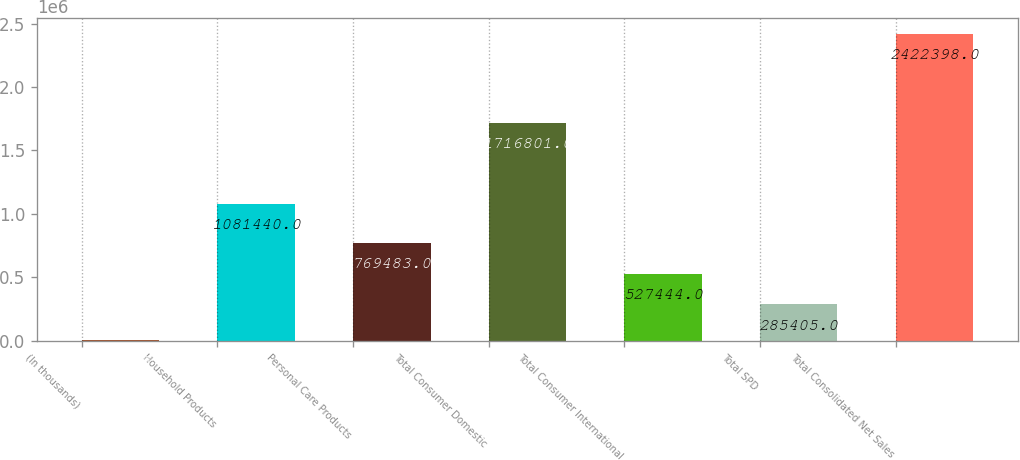<chart> <loc_0><loc_0><loc_500><loc_500><bar_chart><fcel>(In thousands)<fcel>Household Products<fcel>Personal Care Products<fcel>Total Consumer Domestic<fcel>Total Consumer International<fcel>Total SPD<fcel>Total Consolidated Net Sales<nl><fcel>2008<fcel>1.08144e+06<fcel>769483<fcel>1.7168e+06<fcel>527444<fcel>285405<fcel>2.4224e+06<nl></chart> 